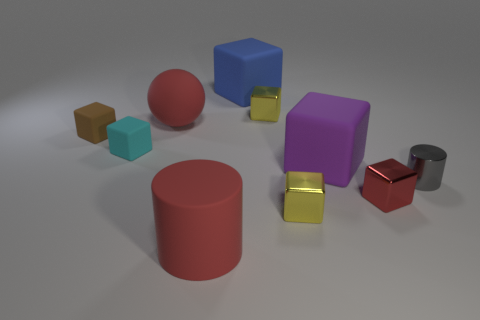Subtract all brown rubber cubes. How many cubes are left? 6 Subtract all cyan cubes. How many cubes are left? 6 Subtract 4 blocks. How many blocks are left? 3 Subtract all gray blocks. Subtract all yellow balls. How many blocks are left? 7 Subtract all cubes. How many objects are left? 3 Add 6 big purple matte cubes. How many big purple matte cubes are left? 7 Add 6 small gray metallic objects. How many small gray metallic objects exist? 7 Subtract 0 brown balls. How many objects are left? 10 Subtract all small spheres. Subtract all yellow things. How many objects are left? 8 